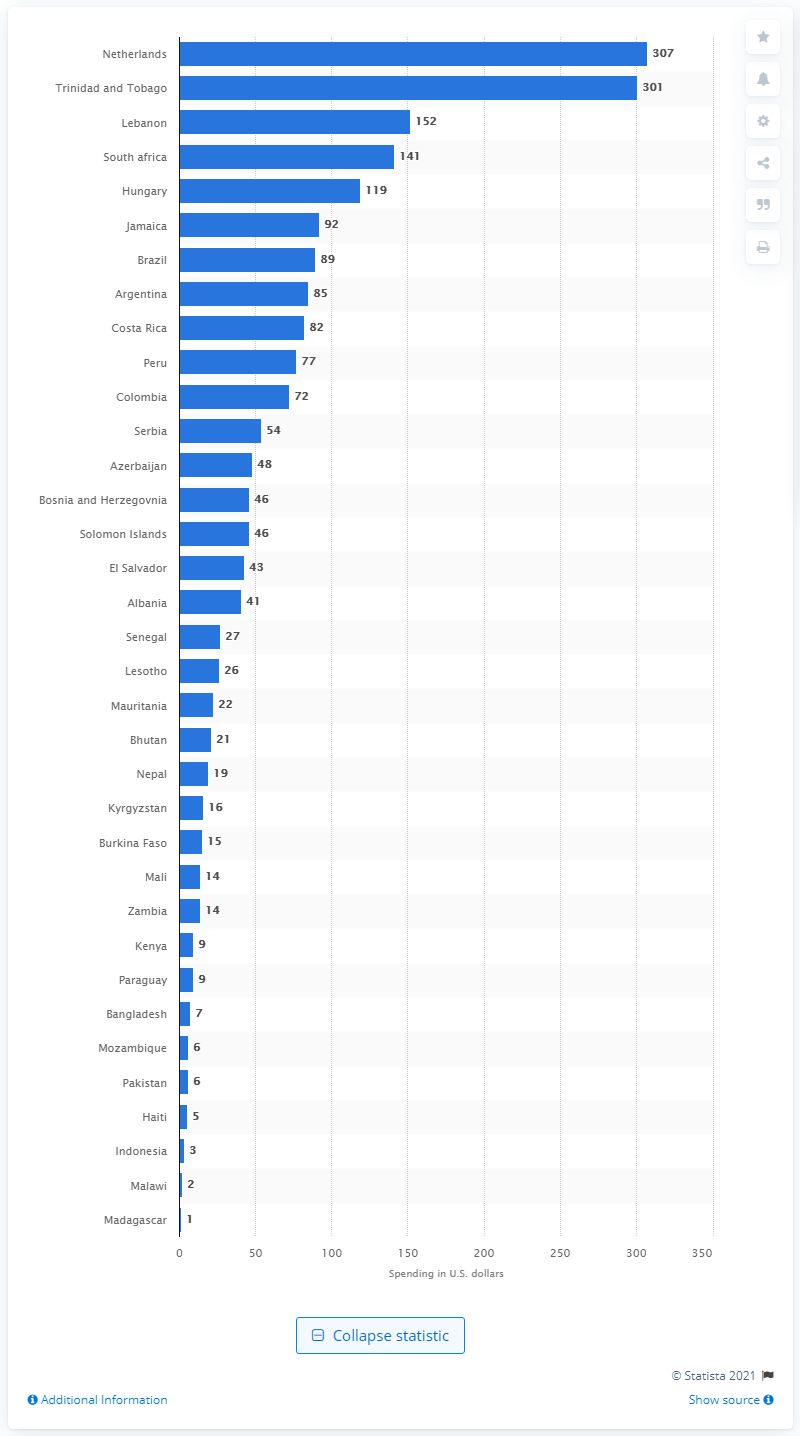Indicate a few pertinent items in this graphic. According to the provided information, it can be concluded that Indonesia spends approximately 3 U.S. dollars per capita on water, sanitation, and hygiene. Brazil spends approximately $89 per person on water, sanitation, and hygiene. 